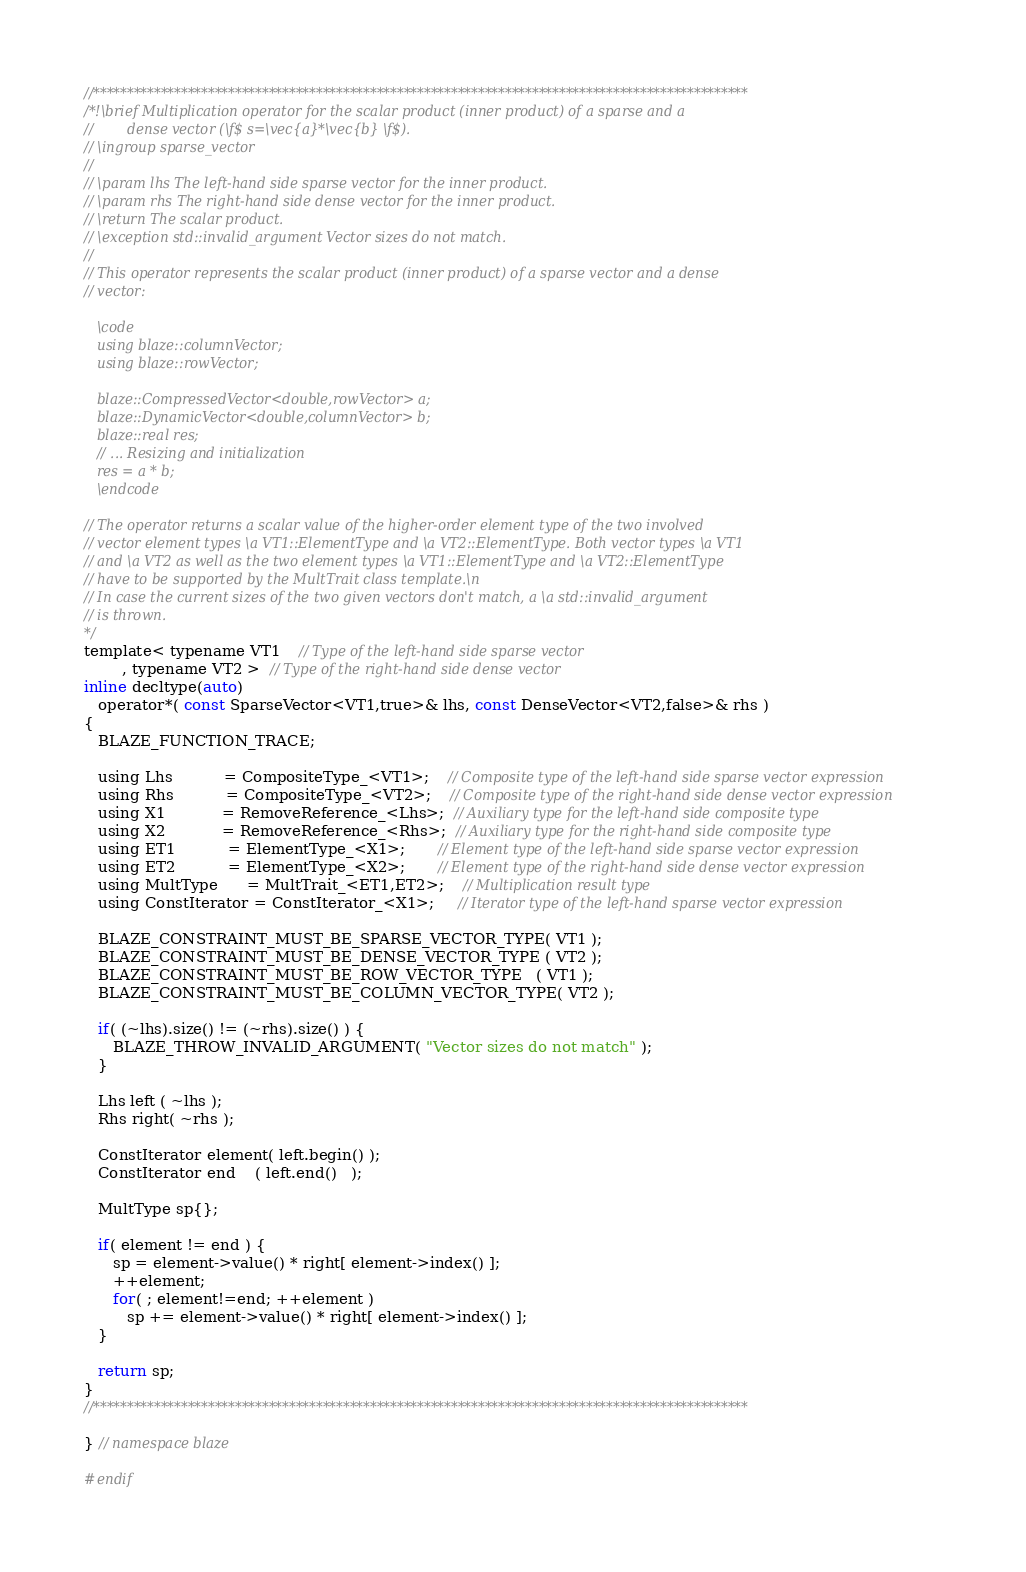Convert code to text. <code><loc_0><loc_0><loc_500><loc_500><_C_>//*************************************************************************************************
/*!\brief Multiplication operator for the scalar product (inner product) of a sparse and a
//        dense vector (\f$ s=\vec{a}*\vec{b} \f$).
// \ingroup sparse_vector
//
// \param lhs The left-hand side sparse vector for the inner product.
// \param rhs The right-hand side dense vector for the inner product.
// \return The scalar product.
// \exception std::invalid_argument Vector sizes do not match.
//
// This operator represents the scalar product (inner product) of a sparse vector and a dense
// vector:

   \code
   using blaze::columnVector;
   using blaze::rowVector;

   blaze::CompressedVector<double,rowVector> a;
   blaze::DynamicVector<double,columnVector> b;
   blaze::real res;
   // ... Resizing and initialization
   res = a * b;
   \endcode

// The operator returns a scalar value of the higher-order element type of the two involved
// vector element types \a VT1::ElementType and \a VT2::ElementType. Both vector types \a VT1
// and \a VT2 as well as the two element types \a VT1::ElementType and \a VT2::ElementType
// have to be supported by the MultTrait class template.\n
// In case the current sizes of the two given vectors don't match, a \a std::invalid_argument
// is thrown.
*/
template< typename VT1    // Type of the left-hand side sparse vector
        , typename VT2 >  // Type of the right-hand side dense vector
inline decltype(auto)
   operator*( const SparseVector<VT1,true>& lhs, const DenseVector<VT2,false>& rhs )
{
   BLAZE_FUNCTION_TRACE;

   using Lhs           = CompositeType_<VT1>;    // Composite type of the left-hand side sparse vector expression
   using Rhs           = CompositeType_<VT2>;    // Composite type of the right-hand side dense vector expression
   using X1            = RemoveReference_<Lhs>;  // Auxiliary type for the left-hand side composite type
   using X2            = RemoveReference_<Rhs>;  // Auxiliary type for the right-hand side composite type
   using ET1           = ElementType_<X1>;       // Element type of the left-hand side sparse vector expression
   using ET2           = ElementType_<X2>;       // Element type of the right-hand side dense vector expression
   using MultType      = MultTrait_<ET1,ET2>;    // Multiplication result type
   using ConstIterator = ConstIterator_<X1>;     // Iterator type of the left-hand sparse vector expression

   BLAZE_CONSTRAINT_MUST_BE_SPARSE_VECTOR_TYPE( VT1 );
   BLAZE_CONSTRAINT_MUST_BE_DENSE_VECTOR_TYPE ( VT2 );
   BLAZE_CONSTRAINT_MUST_BE_ROW_VECTOR_TYPE   ( VT1 );
   BLAZE_CONSTRAINT_MUST_BE_COLUMN_VECTOR_TYPE( VT2 );

   if( (~lhs).size() != (~rhs).size() ) {
      BLAZE_THROW_INVALID_ARGUMENT( "Vector sizes do not match" );
   }

   Lhs left ( ~lhs );
   Rhs right( ~rhs );

   ConstIterator element( left.begin() );
   ConstIterator end    ( left.end()   );

   MultType sp{};

   if( element != end ) {
      sp = element->value() * right[ element->index() ];
      ++element;
      for( ; element!=end; ++element )
         sp += element->value() * right[ element->index() ];
   }

   return sp;
}
//*************************************************************************************************

} // namespace blaze

#endif
</code> 